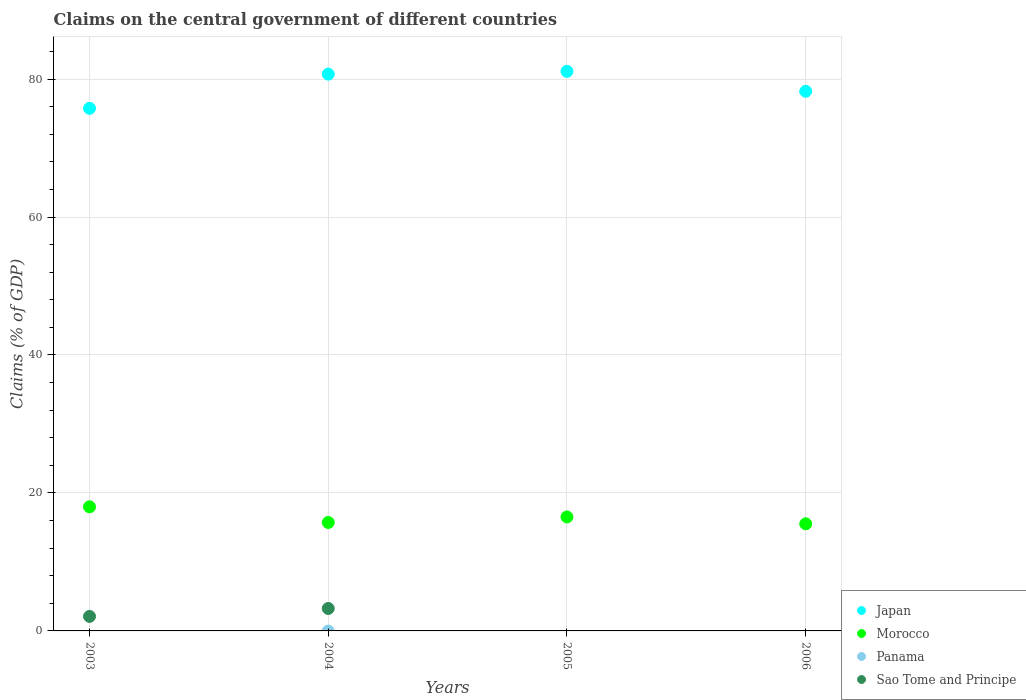How many different coloured dotlines are there?
Keep it short and to the point. 3. What is the percentage of GDP claimed on the central government in Japan in 2003?
Give a very brief answer. 75.75. Across all years, what is the maximum percentage of GDP claimed on the central government in Morocco?
Your answer should be very brief. 17.99. What is the total percentage of GDP claimed on the central government in Sao Tome and Principe in the graph?
Make the answer very short. 5.36. What is the difference between the percentage of GDP claimed on the central government in Japan in 2005 and that in 2006?
Ensure brevity in your answer.  2.89. What is the difference between the percentage of GDP claimed on the central government in Panama in 2006 and the percentage of GDP claimed on the central government in Morocco in 2004?
Provide a succinct answer. -15.72. What is the average percentage of GDP claimed on the central government in Morocco per year?
Offer a terse response. 16.44. In the year 2004, what is the difference between the percentage of GDP claimed on the central government in Morocco and percentage of GDP claimed on the central government in Japan?
Offer a terse response. -64.99. In how many years, is the percentage of GDP claimed on the central government in Panama greater than 48 %?
Offer a very short reply. 0. What is the ratio of the percentage of GDP claimed on the central government in Morocco in 2004 to that in 2006?
Offer a terse response. 1.01. Is the difference between the percentage of GDP claimed on the central government in Morocco in 2004 and 2005 greater than the difference between the percentage of GDP claimed on the central government in Japan in 2004 and 2005?
Your answer should be very brief. No. What is the difference between the highest and the second highest percentage of GDP claimed on the central government in Morocco?
Provide a short and direct response. 1.47. What is the difference between the highest and the lowest percentage of GDP claimed on the central government in Japan?
Offer a terse response. 5.36. Is the sum of the percentage of GDP claimed on the central government in Morocco in 2003 and 2006 greater than the maximum percentage of GDP claimed on the central government in Panama across all years?
Offer a terse response. Yes. Is it the case that in every year, the sum of the percentage of GDP claimed on the central government in Sao Tome and Principe and percentage of GDP claimed on the central government in Panama  is greater than the sum of percentage of GDP claimed on the central government in Japan and percentage of GDP claimed on the central government in Morocco?
Keep it short and to the point. No. Does the percentage of GDP claimed on the central government in Panama monotonically increase over the years?
Offer a very short reply. No. Is the percentage of GDP claimed on the central government in Morocco strictly greater than the percentage of GDP claimed on the central government in Japan over the years?
Make the answer very short. No. How many dotlines are there?
Keep it short and to the point. 3. What is the difference between two consecutive major ticks on the Y-axis?
Provide a succinct answer. 20. Are the values on the major ticks of Y-axis written in scientific E-notation?
Provide a short and direct response. No. Does the graph contain grids?
Provide a succinct answer. Yes. How are the legend labels stacked?
Your response must be concise. Vertical. What is the title of the graph?
Your answer should be very brief. Claims on the central government of different countries. Does "Europe(developing only)" appear as one of the legend labels in the graph?
Offer a very short reply. No. What is the label or title of the Y-axis?
Provide a succinct answer. Claims (% of GDP). What is the Claims (% of GDP) in Japan in 2003?
Provide a succinct answer. 75.75. What is the Claims (% of GDP) in Morocco in 2003?
Provide a short and direct response. 17.99. What is the Claims (% of GDP) in Panama in 2003?
Offer a terse response. 0. What is the Claims (% of GDP) in Sao Tome and Principe in 2003?
Give a very brief answer. 2.1. What is the Claims (% of GDP) in Japan in 2004?
Your answer should be very brief. 80.71. What is the Claims (% of GDP) of Morocco in 2004?
Offer a terse response. 15.72. What is the Claims (% of GDP) of Sao Tome and Principe in 2004?
Provide a short and direct response. 3.25. What is the Claims (% of GDP) in Japan in 2005?
Your answer should be very brief. 81.11. What is the Claims (% of GDP) of Morocco in 2005?
Offer a very short reply. 16.52. What is the Claims (% of GDP) in Sao Tome and Principe in 2005?
Make the answer very short. 0. What is the Claims (% of GDP) of Japan in 2006?
Offer a terse response. 78.23. What is the Claims (% of GDP) of Morocco in 2006?
Offer a very short reply. 15.53. Across all years, what is the maximum Claims (% of GDP) in Japan?
Your answer should be very brief. 81.11. Across all years, what is the maximum Claims (% of GDP) of Morocco?
Provide a succinct answer. 17.99. Across all years, what is the maximum Claims (% of GDP) of Sao Tome and Principe?
Your answer should be very brief. 3.25. Across all years, what is the minimum Claims (% of GDP) of Japan?
Your response must be concise. 75.75. Across all years, what is the minimum Claims (% of GDP) of Morocco?
Make the answer very short. 15.53. What is the total Claims (% of GDP) in Japan in the graph?
Your answer should be very brief. 315.8. What is the total Claims (% of GDP) of Morocco in the graph?
Offer a very short reply. 65.76. What is the total Claims (% of GDP) in Sao Tome and Principe in the graph?
Ensure brevity in your answer.  5.36. What is the difference between the Claims (% of GDP) in Japan in 2003 and that in 2004?
Make the answer very short. -4.96. What is the difference between the Claims (% of GDP) in Morocco in 2003 and that in 2004?
Provide a short and direct response. 2.27. What is the difference between the Claims (% of GDP) in Sao Tome and Principe in 2003 and that in 2004?
Keep it short and to the point. -1.15. What is the difference between the Claims (% of GDP) of Japan in 2003 and that in 2005?
Your answer should be very brief. -5.36. What is the difference between the Claims (% of GDP) of Morocco in 2003 and that in 2005?
Offer a terse response. 1.47. What is the difference between the Claims (% of GDP) of Japan in 2003 and that in 2006?
Offer a terse response. -2.47. What is the difference between the Claims (% of GDP) of Morocco in 2003 and that in 2006?
Provide a succinct answer. 2.46. What is the difference between the Claims (% of GDP) in Japan in 2004 and that in 2005?
Provide a short and direct response. -0.4. What is the difference between the Claims (% of GDP) in Morocco in 2004 and that in 2005?
Keep it short and to the point. -0.8. What is the difference between the Claims (% of GDP) in Japan in 2004 and that in 2006?
Your answer should be very brief. 2.49. What is the difference between the Claims (% of GDP) in Morocco in 2004 and that in 2006?
Provide a short and direct response. 0.19. What is the difference between the Claims (% of GDP) in Japan in 2005 and that in 2006?
Your answer should be compact. 2.89. What is the difference between the Claims (% of GDP) of Japan in 2003 and the Claims (% of GDP) of Morocco in 2004?
Your answer should be very brief. 60.03. What is the difference between the Claims (% of GDP) of Japan in 2003 and the Claims (% of GDP) of Sao Tome and Principe in 2004?
Ensure brevity in your answer.  72.5. What is the difference between the Claims (% of GDP) in Morocco in 2003 and the Claims (% of GDP) in Sao Tome and Principe in 2004?
Offer a very short reply. 14.74. What is the difference between the Claims (% of GDP) of Japan in 2003 and the Claims (% of GDP) of Morocco in 2005?
Your answer should be compact. 59.24. What is the difference between the Claims (% of GDP) of Japan in 2003 and the Claims (% of GDP) of Morocco in 2006?
Your answer should be very brief. 60.23. What is the difference between the Claims (% of GDP) in Japan in 2004 and the Claims (% of GDP) in Morocco in 2005?
Provide a short and direct response. 64.19. What is the difference between the Claims (% of GDP) of Japan in 2004 and the Claims (% of GDP) of Morocco in 2006?
Ensure brevity in your answer.  65.18. What is the difference between the Claims (% of GDP) of Japan in 2005 and the Claims (% of GDP) of Morocco in 2006?
Make the answer very short. 65.58. What is the average Claims (% of GDP) in Japan per year?
Offer a very short reply. 78.95. What is the average Claims (% of GDP) in Morocco per year?
Make the answer very short. 16.44. What is the average Claims (% of GDP) of Panama per year?
Make the answer very short. 0. What is the average Claims (% of GDP) in Sao Tome and Principe per year?
Ensure brevity in your answer.  1.34. In the year 2003, what is the difference between the Claims (% of GDP) in Japan and Claims (% of GDP) in Morocco?
Offer a very short reply. 57.76. In the year 2003, what is the difference between the Claims (% of GDP) in Japan and Claims (% of GDP) in Sao Tome and Principe?
Your response must be concise. 73.65. In the year 2003, what is the difference between the Claims (% of GDP) in Morocco and Claims (% of GDP) in Sao Tome and Principe?
Your answer should be very brief. 15.89. In the year 2004, what is the difference between the Claims (% of GDP) in Japan and Claims (% of GDP) in Morocco?
Offer a very short reply. 64.99. In the year 2004, what is the difference between the Claims (% of GDP) in Japan and Claims (% of GDP) in Sao Tome and Principe?
Keep it short and to the point. 77.46. In the year 2004, what is the difference between the Claims (% of GDP) in Morocco and Claims (% of GDP) in Sao Tome and Principe?
Your answer should be very brief. 12.47. In the year 2005, what is the difference between the Claims (% of GDP) of Japan and Claims (% of GDP) of Morocco?
Make the answer very short. 64.59. In the year 2006, what is the difference between the Claims (% of GDP) of Japan and Claims (% of GDP) of Morocco?
Your response must be concise. 62.7. What is the ratio of the Claims (% of GDP) of Japan in 2003 to that in 2004?
Your answer should be compact. 0.94. What is the ratio of the Claims (% of GDP) in Morocco in 2003 to that in 2004?
Give a very brief answer. 1.14. What is the ratio of the Claims (% of GDP) of Sao Tome and Principe in 2003 to that in 2004?
Give a very brief answer. 0.65. What is the ratio of the Claims (% of GDP) of Japan in 2003 to that in 2005?
Your answer should be very brief. 0.93. What is the ratio of the Claims (% of GDP) of Morocco in 2003 to that in 2005?
Provide a short and direct response. 1.09. What is the ratio of the Claims (% of GDP) in Japan in 2003 to that in 2006?
Provide a succinct answer. 0.97. What is the ratio of the Claims (% of GDP) of Morocco in 2003 to that in 2006?
Provide a succinct answer. 1.16. What is the ratio of the Claims (% of GDP) in Morocco in 2004 to that in 2005?
Offer a terse response. 0.95. What is the ratio of the Claims (% of GDP) of Japan in 2004 to that in 2006?
Your answer should be compact. 1.03. What is the ratio of the Claims (% of GDP) in Morocco in 2004 to that in 2006?
Ensure brevity in your answer.  1.01. What is the ratio of the Claims (% of GDP) in Japan in 2005 to that in 2006?
Provide a short and direct response. 1.04. What is the ratio of the Claims (% of GDP) of Morocco in 2005 to that in 2006?
Give a very brief answer. 1.06. What is the difference between the highest and the second highest Claims (% of GDP) of Japan?
Give a very brief answer. 0.4. What is the difference between the highest and the second highest Claims (% of GDP) in Morocco?
Offer a very short reply. 1.47. What is the difference between the highest and the lowest Claims (% of GDP) in Japan?
Offer a terse response. 5.36. What is the difference between the highest and the lowest Claims (% of GDP) in Morocco?
Make the answer very short. 2.46. What is the difference between the highest and the lowest Claims (% of GDP) of Sao Tome and Principe?
Your answer should be compact. 3.25. 